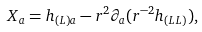<formula> <loc_0><loc_0><loc_500><loc_500>X _ { a } = h _ { ( L ) a } - r ^ { 2 } \partial _ { a } ( r ^ { - 2 } h _ { ( L L ) } ) ,</formula> 